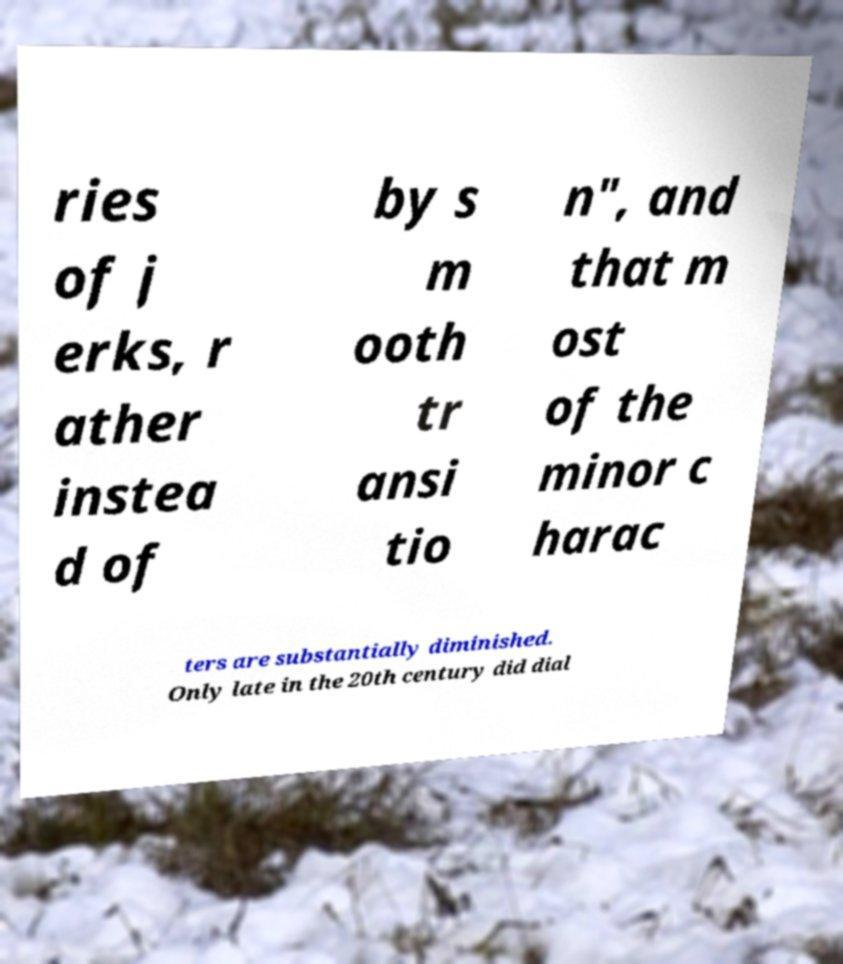Please read and relay the text visible in this image. What does it say? ries of j erks, r ather instea d of by s m ooth tr ansi tio n", and that m ost of the minor c harac ters are substantially diminished. Only late in the 20th century did dial 